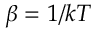<formula> <loc_0><loc_0><loc_500><loc_500>\beta = 1 / k T</formula> 